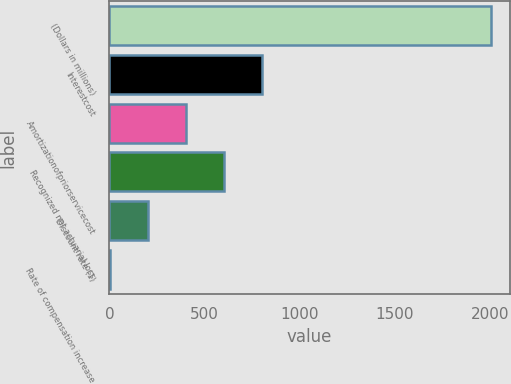Convert chart. <chart><loc_0><loc_0><loc_500><loc_500><bar_chart><fcel>(Dollars in millions)<fcel>Interestcost<fcel>Amortizationofpriorservicecost<fcel>Recognized net actuarial loss<fcel>Discount rate (1)<fcel>Rate of compensation increase<nl><fcel>2005<fcel>804.4<fcel>404.2<fcel>604.3<fcel>204.1<fcel>4<nl></chart> 